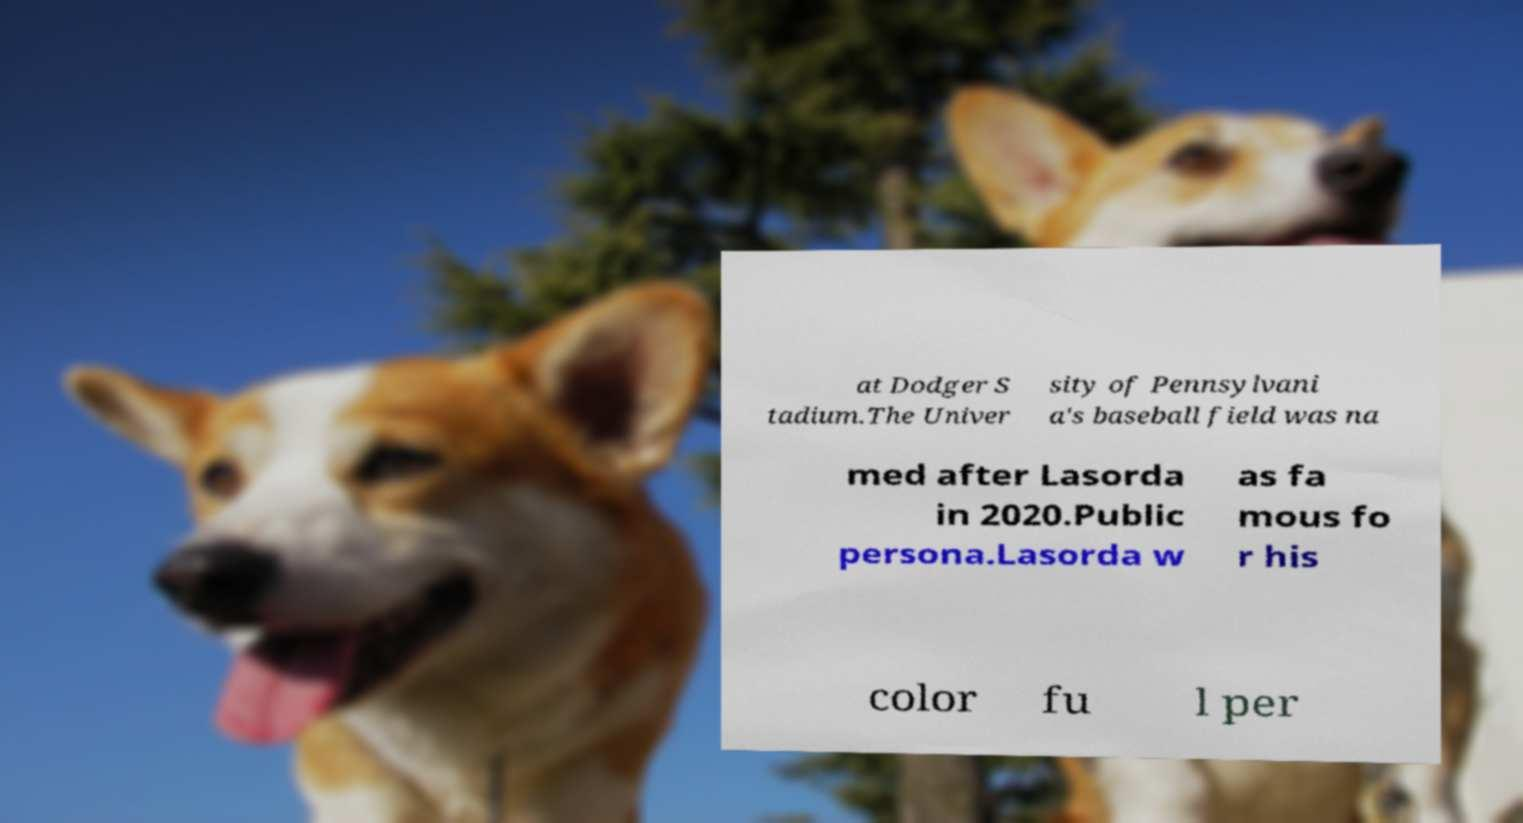Could you extract and type out the text from this image? at Dodger S tadium.The Univer sity of Pennsylvani a's baseball field was na med after Lasorda in 2020.Public persona.Lasorda w as fa mous fo r his color fu l per 